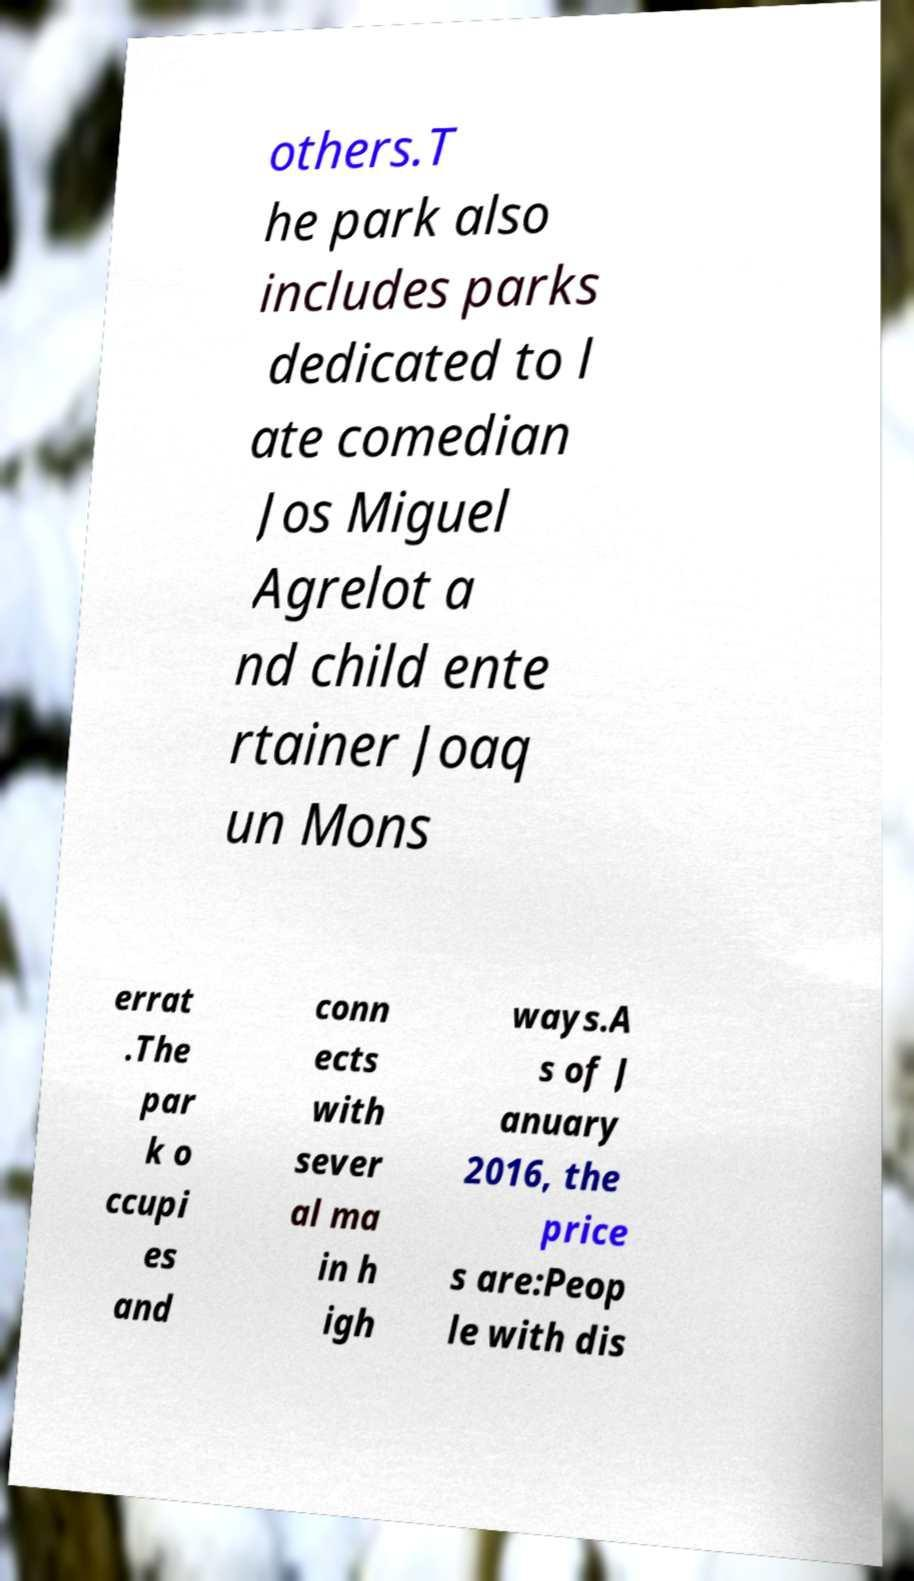I need the written content from this picture converted into text. Can you do that? others.T he park also includes parks dedicated to l ate comedian Jos Miguel Agrelot a nd child ente rtainer Joaq un Mons errat .The par k o ccupi es and conn ects with sever al ma in h igh ways.A s of J anuary 2016, the price s are:Peop le with dis 